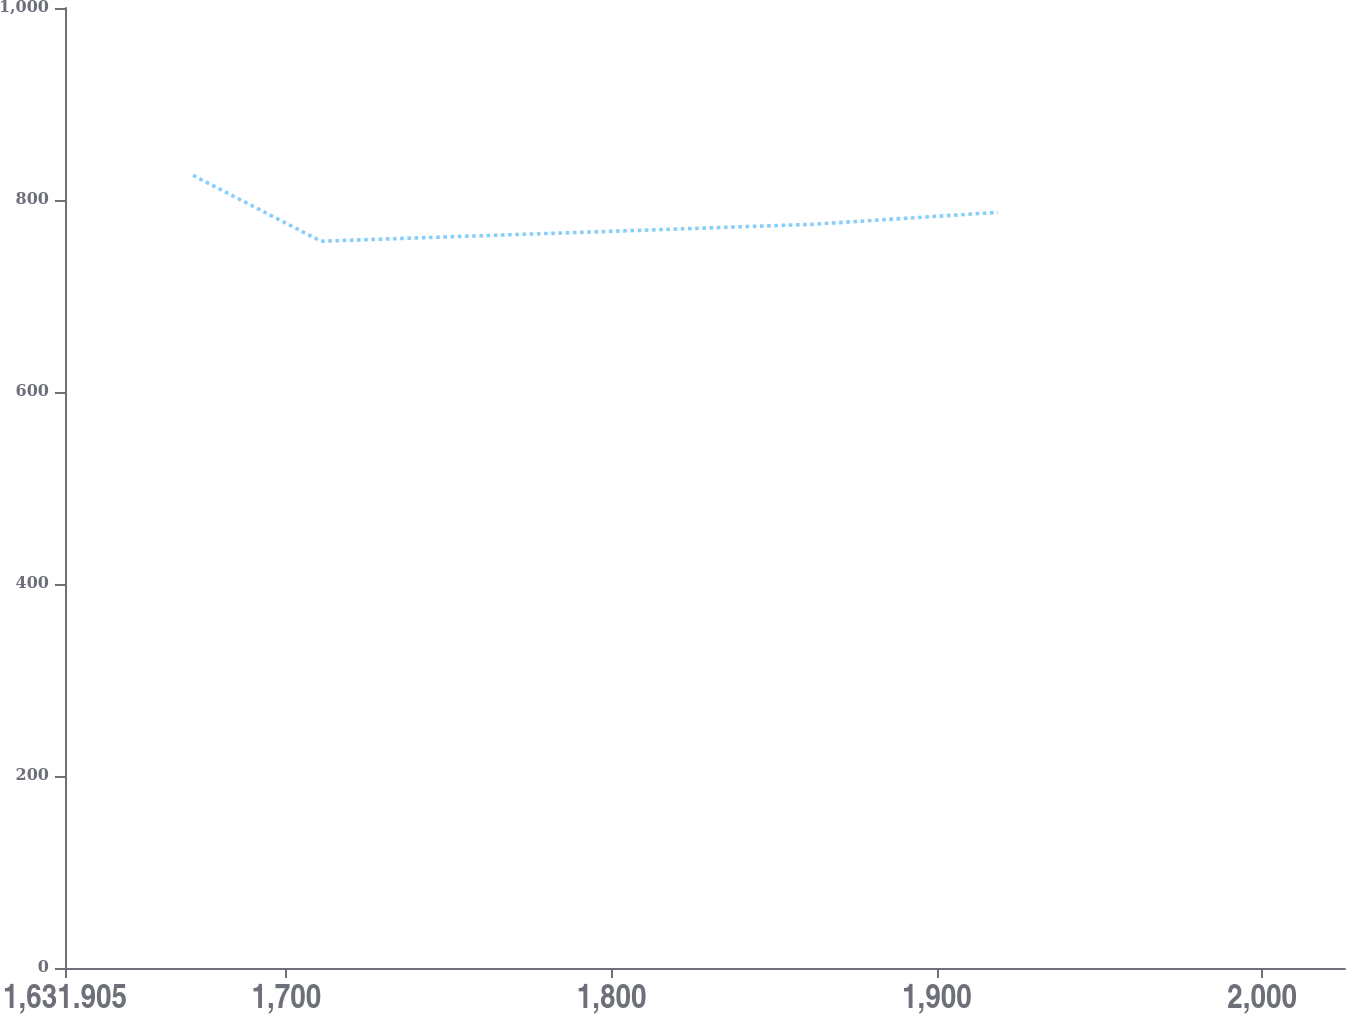Convert chart. <chart><loc_0><loc_0><loc_500><loc_500><line_chart><ecel><fcel>Unnamed: 1<nl><fcel>1671.26<fcel>825.69<nl><fcel>1710.62<fcel>757.04<nl><fcel>1861.45<fcel>774.6<nl><fcel>1918.7<fcel>787.15<nl><fcel>2064.81<fcel>882.54<nl></chart> 